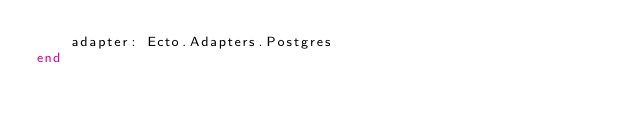<code> <loc_0><loc_0><loc_500><loc_500><_Elixir_>    adapter: Ecto.Adapters.Postgres
end
</code> 